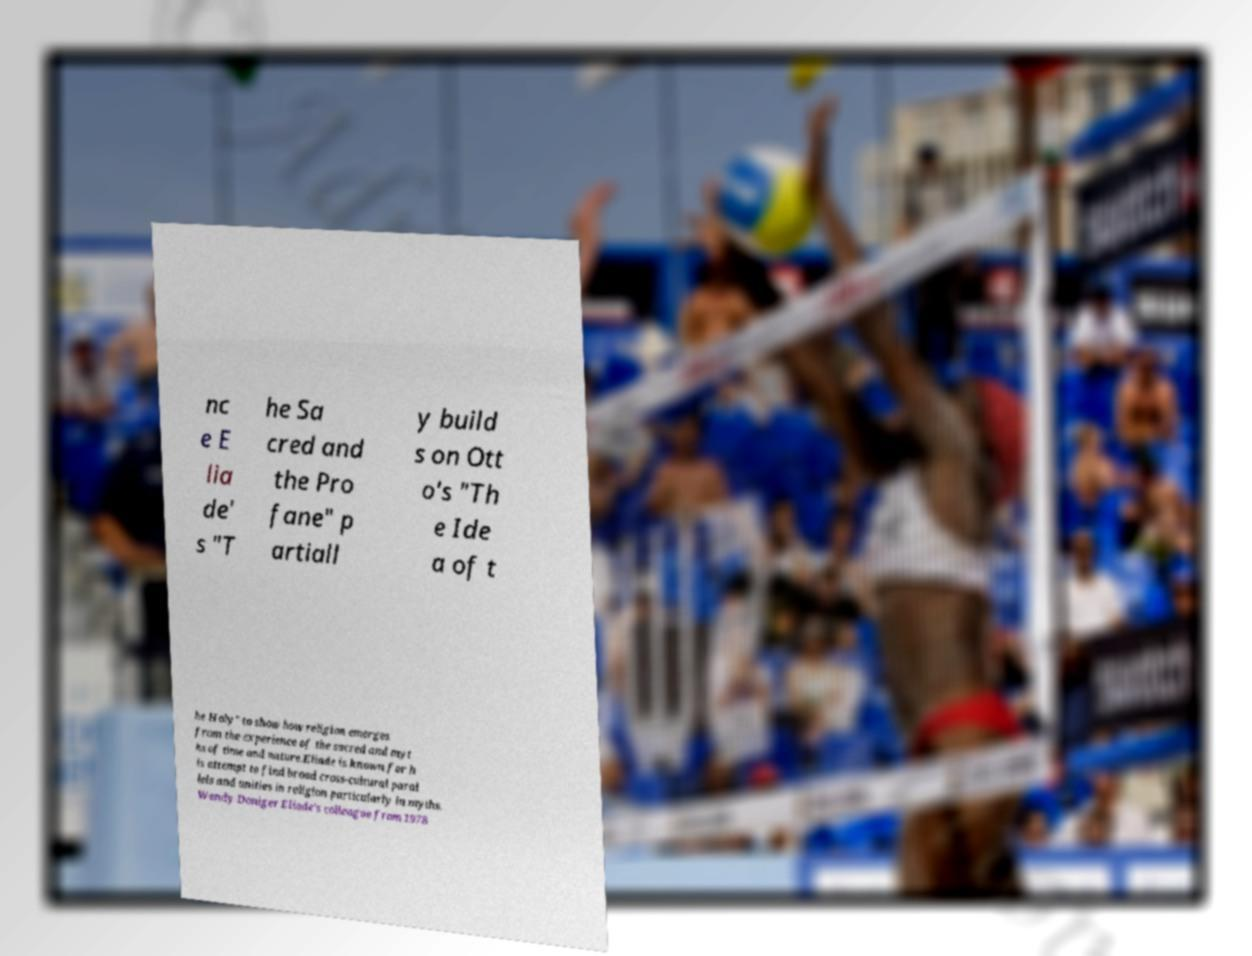Could you extract and type out the text from this image? nc e E lia de' s "T he Sa cred and the Pro fane" p artiall y build s on Ott o's "Th e Ide a of t he Holy" to show how religion emerges from the experience of the sacred and myt hs of time and nature.Eliade is known for h is attempt to find broad cross-cultural paral lels and unities in religion particularly in myths. Wendy Doniger Eliade's colleague from 1978 